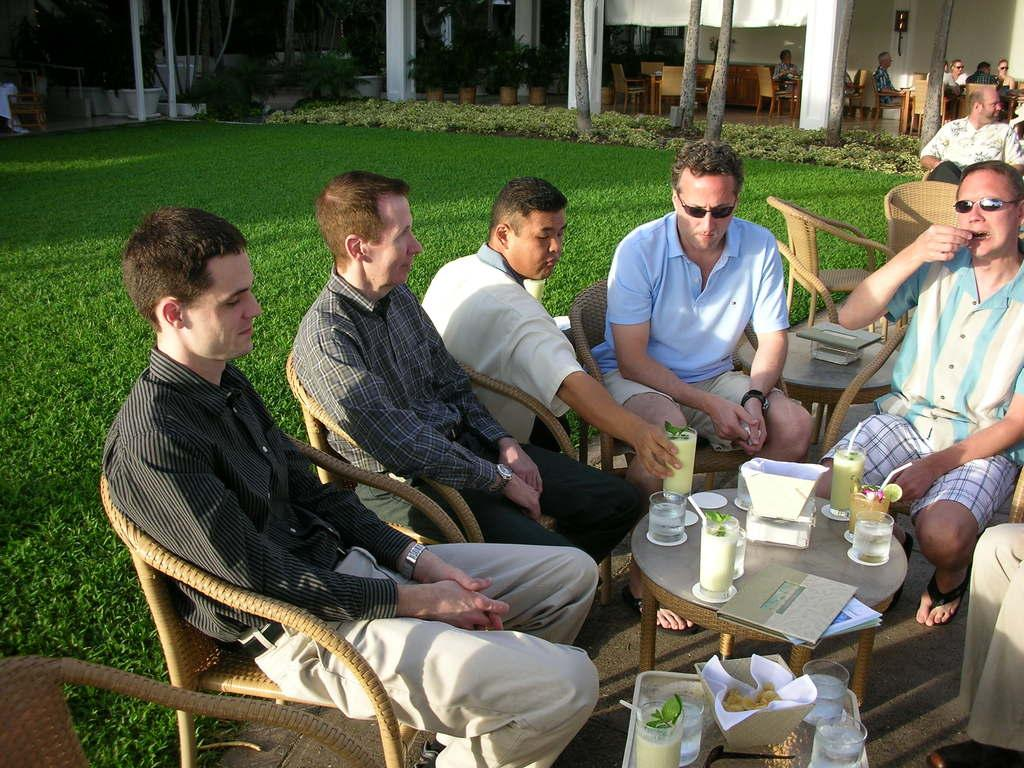What type of vegetation is present in the image? There is grass in the image. What structure can be seen in the image? There is a wall in the image. What are the people in the image doing? The people are sitting on chairs in the image. What furniture is present in the image? There is a table in the image. What items can be seen on the table? There are glasses and tissues on the table. Can you tell me which judge is presiding over the case in the image? There is no judge or case present in the image; it features grass, a wall, people sitting on chairs, a table, glasses, and tissues. Is there a bat visible in the image? There is no bat present in the image. 